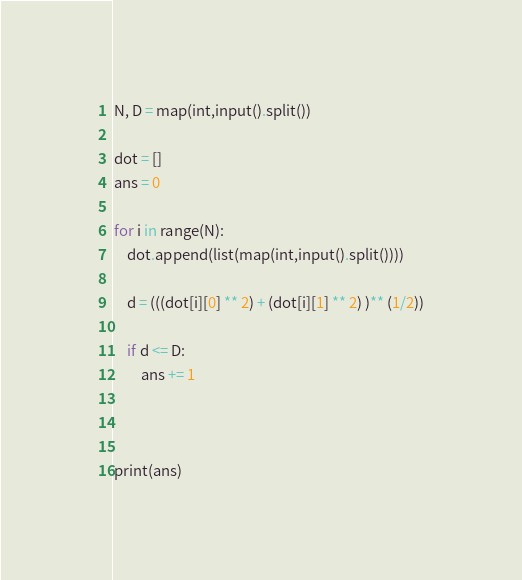Convert code to text. <code><loc_0><loc_0><loc_500><loc_500><_Python_>N, D = map(int,input().split())

dot = []
ans = 0

for i in range(N):
    dot.append(list(map(int,input().split())))

    d = (((dot[i][0] ** 2) + (dot[i][1] ** 2) )** (1/2))

    if d <= D:
        ans += 1



print(ans)


</code> 